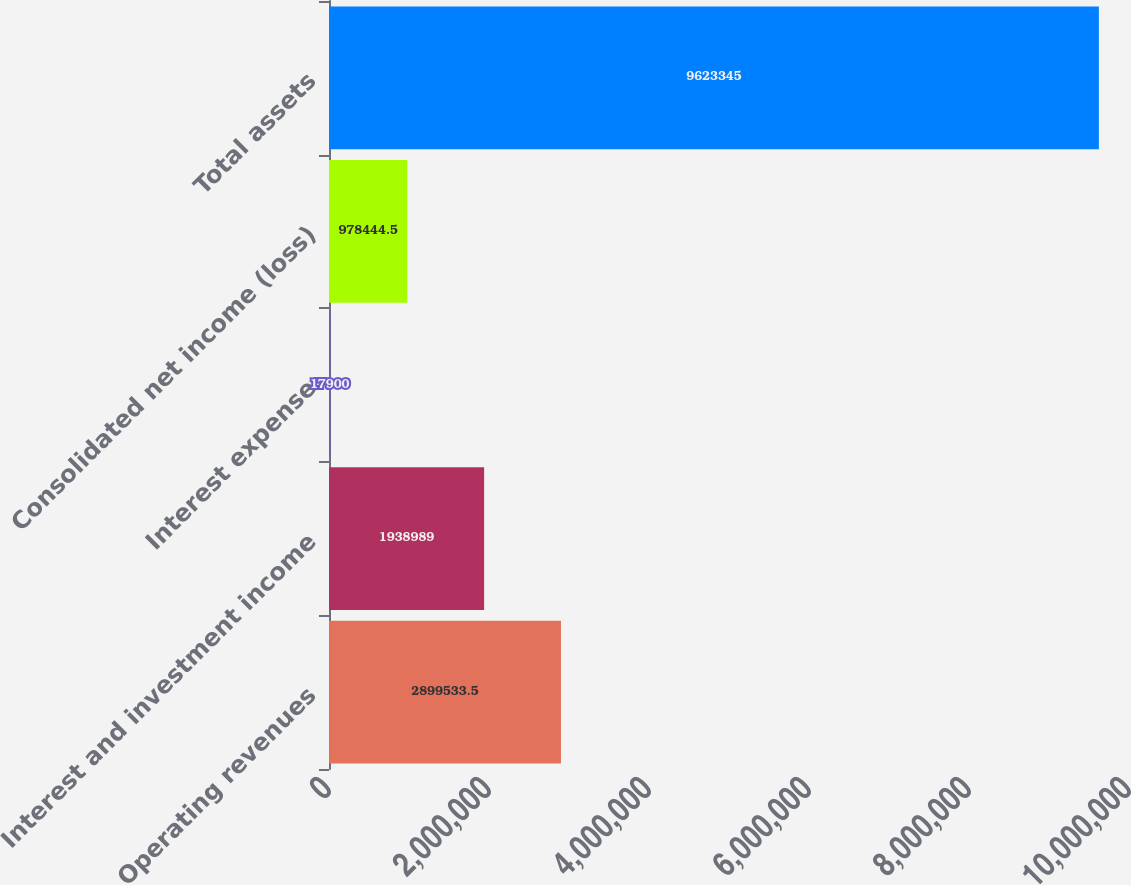Convert chart. <chart><loc_0><loc_0><loc_500><loc_500><bar_chart><fcel>Operating revenues<fcel>Interest and investment income<fcel>Interest expense<fcel>Consolidated net income (loss)<fcel>Total assets<nl><fcel>2.89953e+06<fcel>1.93899e+06<fcel>17900<fcel>978444<fcel>9.62334e+06<nl></chart> 